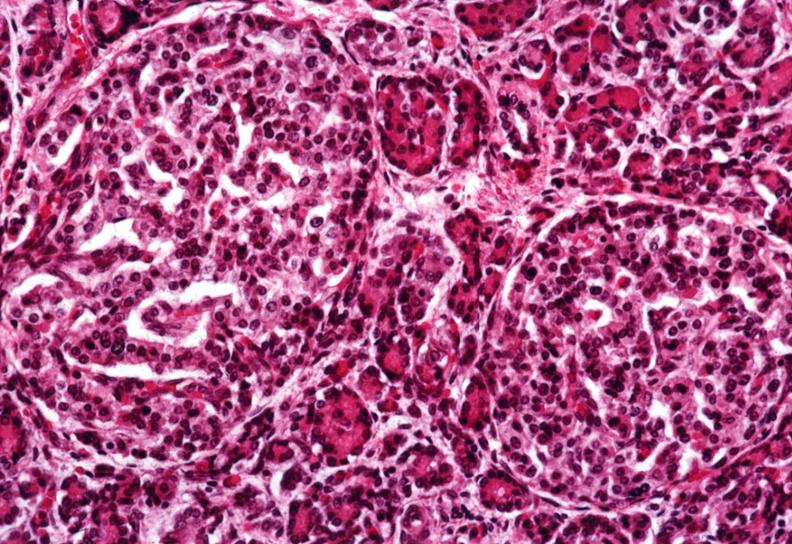what is present?
Answer the question using a single word or phrase. Pancreas 